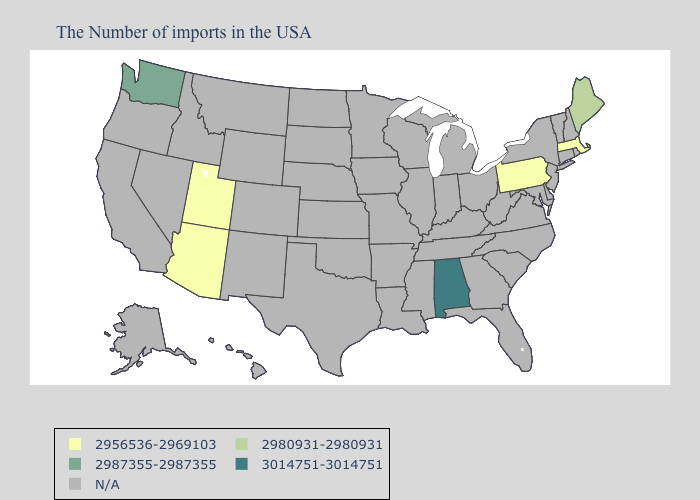What is the value of Alabama?
Concise answer only. 3014751-3014751. Among the states that border New Hampshire , does Maine have the lowest value?
Write a very short answer. No. Which states have the lowest value in the West?
Keep it brief. Utah, Arizona. Does the map have missing data?
Concise answer only. Yes. Which states have the highest value in the USA?
Be succinct. Alabama. Does Maine have the lowest value in the USA?
Keep it brief. No. Which states have the highest value in the USA?
Quick response, please. Alabama. Which states have the highest value in the USA?
Write a very short answer. Alabama. Is the legend a continuous bar?
Be succinct. No. What is the value of Kentucky?
Concise answer only. N/A. 